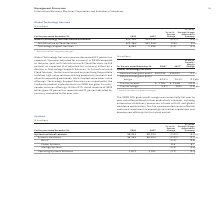According to International Business Machines's financial document, What are the benefits reflected from gross profit margin? The 2018 GTS gross profit margin was essentially flat year to year and reflected benefits from productivity initiatives. The document states: "The 2018 GTS gross profit margin was essentially flat year to year and reflected benefits from productivity initiatives, including automation of deliv..." Also, What does the productivity initiatives include? automation of delivery processes infused with AI and global workforce optimization.. The document states: "benefits from productivity initiatives, including automation of delivery processes infused with AI and global workforce optimization. Pre-tax income p..." Also, What does the Pre-tax income performance implied?  Pre-tax income performance reflected continued investment to expand go-to-market capabilities and develop new offerings for the hybrid market.. The document states: "infused with AI and global workforce optimization. Pre-tax income performance reflected continued investment to expand go-to-market capabilities and d..." Also, can you calculate: What is the average of External total gross profit? To answer this question, I need to perform calculations using the financial data. The calculation is: (10,035+10,022) / 2, which equals 10028.5 (in millions). This is based on the information: "External total gross profit $10,035 $10,022 0.1% External total gross profit $10,035 $10,022 0.1%..." The key data points involved are: 10,022, 10,035. Also, can you calculate: What is the increase/ (decrease) in External total gross profit from 2017 to 2018 Based on the calculation: 10,035-10,022, the result is 13 (in millions). This is based on the information: "External total gross profit $10,035 $10,022 0.1% External total gross profit $10,035 $10,022 0.1%..." The key data points involved are: 10,022, 10,035. Also, can you calculate: What is the increase/ (decrease) in Pre-tax income from 2017 to 2018 Based on the calculation: 1,781-2,618 , the result is -837 (in millions). This is based on the information: "Pre-tax income $ 1,781 $ 2,618 (32.0)% Pre-tax income $ 1,781 $ 2,618 (32.0)%..." The key data points involved are: 1,781, 2,618. 